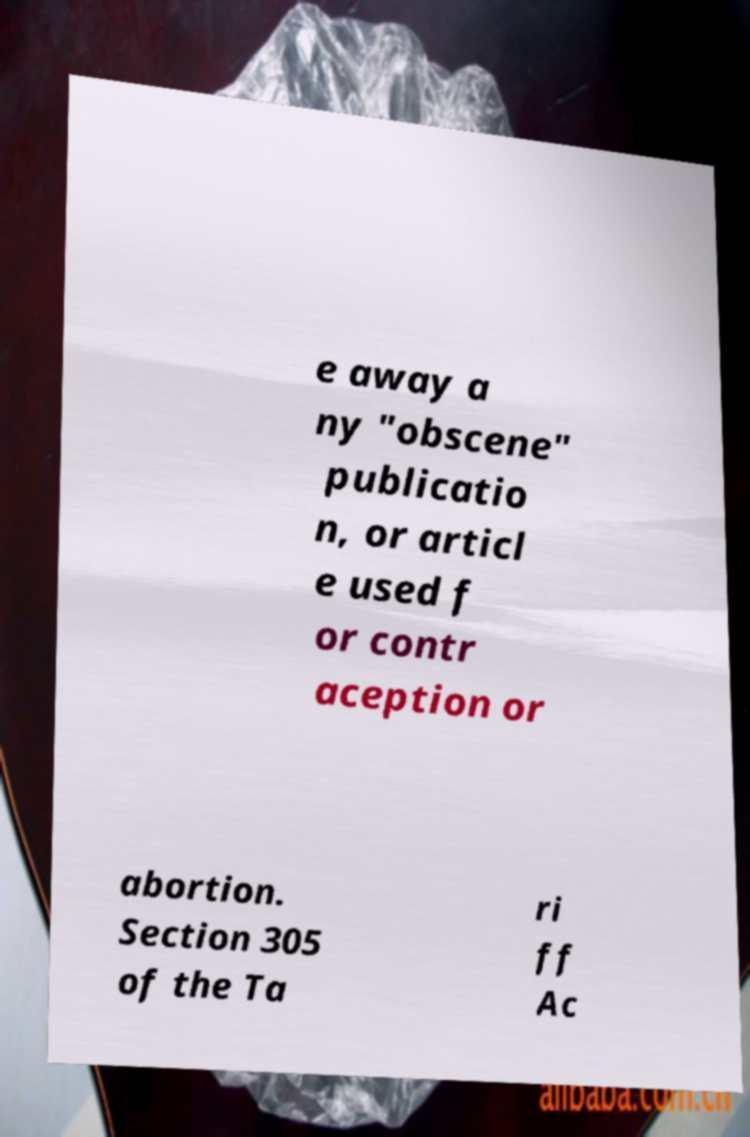Can you read and provide the text displayed in the image?This photo seems to have some interesting text. Can you extract and type it out for me? e away a ny "obscene" publicatio n, or articl e used f or contr aception or abortion. Section 305 of the Ta ri ff Ac 